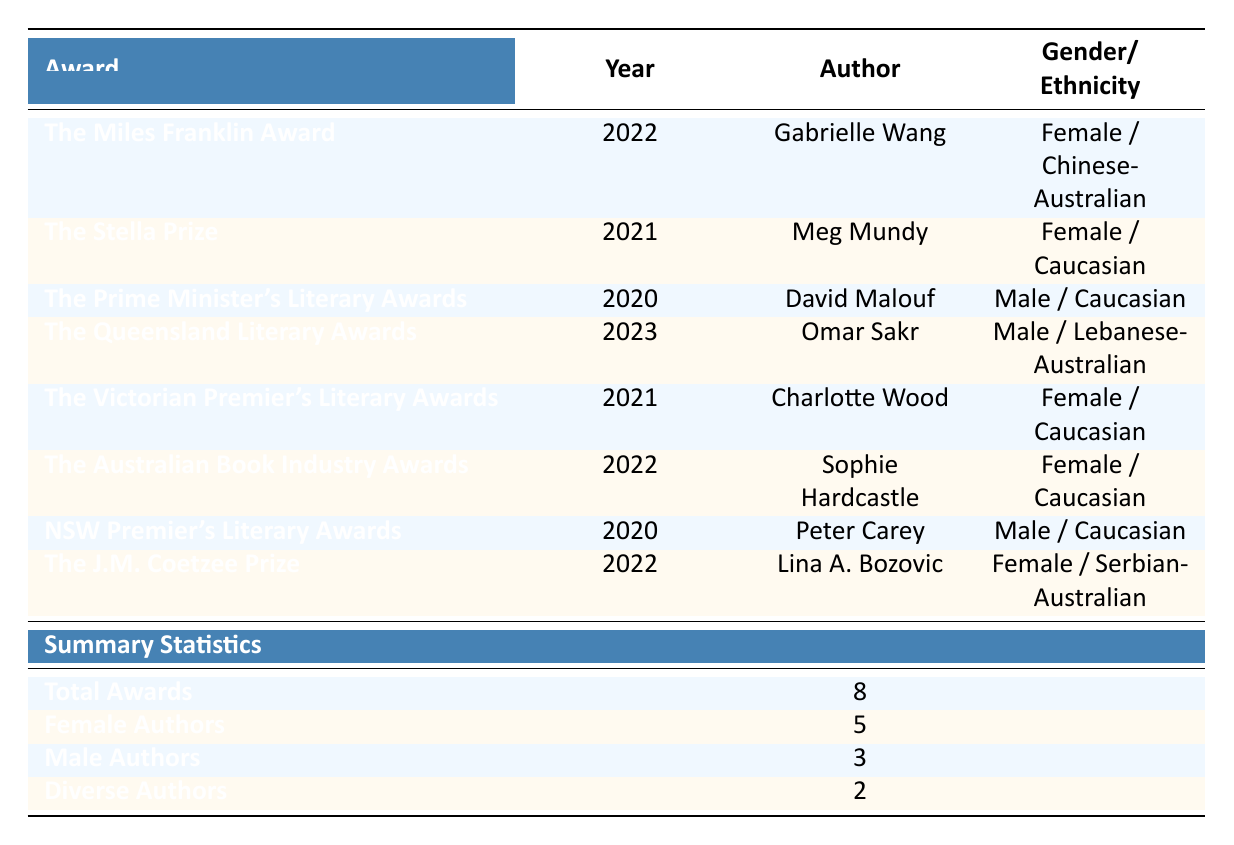What is the total number of literary awards listed? The summary section clearly states that the total number of awards presented is 8.
Answer: 8 How many awards were won by female authors? In the summary, it shows that there are 5 female authors among the listed awards.
Answer: 5 Which author won The Queensland Literary Awards in 2023? The table entry for The Queensland Literary Awards in 2023 reveals that the author who won is Omar Sakr.
Answer: Omar Sakr Did more male authors win literary awards than female authors? The summary indicates that there are 5 female authors and 3 male authors, so yes, more female authors won awards than male authors.
Answer: No What is the ethnicity of the author who won The J.M. Coetzee Prize? The data for The J.M. Coetzee Prize lists Lina A. Bozovic as the author, and her ethnicity is noted as Serbian-Australian.
Answer: Serbian-Australian How many diverse authors are represented in the awards? The summary indicates that there are 2 diverse authors among the award winners.
Answer: 2 What percentage of the total awards were won by female authors? To find the percentage, we take the number of female authors (5) and divide it by the total awards (8), then multiply by 100. Therefore, the calculation is (5/8) * 100 = 62.5%.
Answer: 62.5% Which award had the only male author from a diverse background? The Queensland Literary Awards featured Omar Sakr, who is identified in the table as a male author of Lebanese-Australian descent, making him the only male author from a diverse background in the data set.
Answer: The Queensland Literary Awards How many total awards list authors with non-Caucasian ethnicities? Out of the 8 awards, Gabrielle Wang and Omar Sakr are the authors listed with non-Caucasian ethnicities, which totals 2 awards.
Answer: 2 What year did Charlotte Wood win her award? According to the table, Charlotte Wood won The Victorian Premier's Literary Awards in the year 2021.
Answer: 2021 